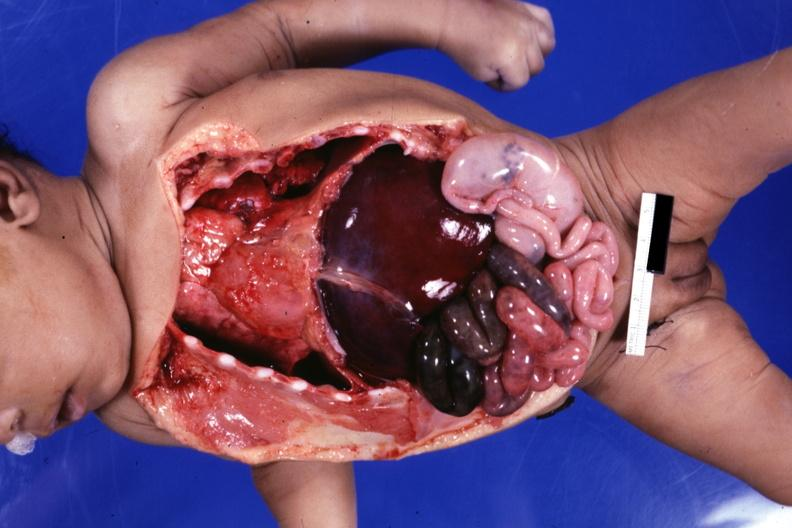what opened showing cardiac apex to right , right liver lobe on left cecum on left gangrenous small bowel?
Answer the question using a single word or phrase. Infant body 